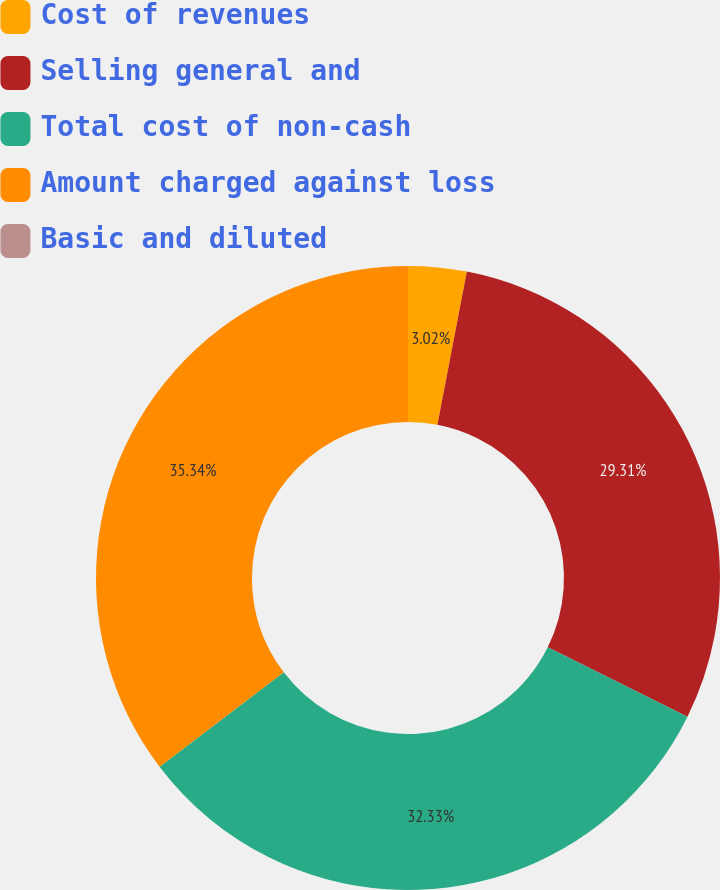<chart> <loc_0><loc_0><loc_500><loc_500><pie_chart><fcel>Cost of revenues<fcel>Selling general and<fcel>Total cost of non-cash<fcel>Amount charged against loss<fcel>Basic and diluted<nl><fcel>3.02%<fcel>29.31%<fcel>32.33%<fcel>35.34%<fcel>0.0%<nl></chart> 